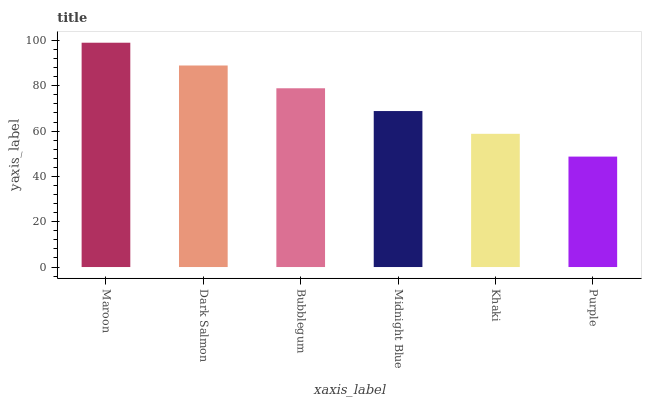Is Dark Salmon the minimum?
Answer yes or no. No. Is Dark Salmon the maximum?
Answer yes or no. No. Is Maroon greater than Dark Salmon?
Answer yes or no. Yes. Is Dark Salmon less than Maroon?
Answer yes or no. Yes. Is Dark Salmon greater than Maroon?
Answer yes or no. No. Is Maroon less than Dark Salmon?
Answer yes or no. No. Is Bubblegum the high median?
Answer yes or no. Yes. Is Midnight Blue the low median?
Answer yes or no. Yes. Is Purple the high median?
Answer yes or no. No. Is Maroon the low median?
Answer yes or no. No. 